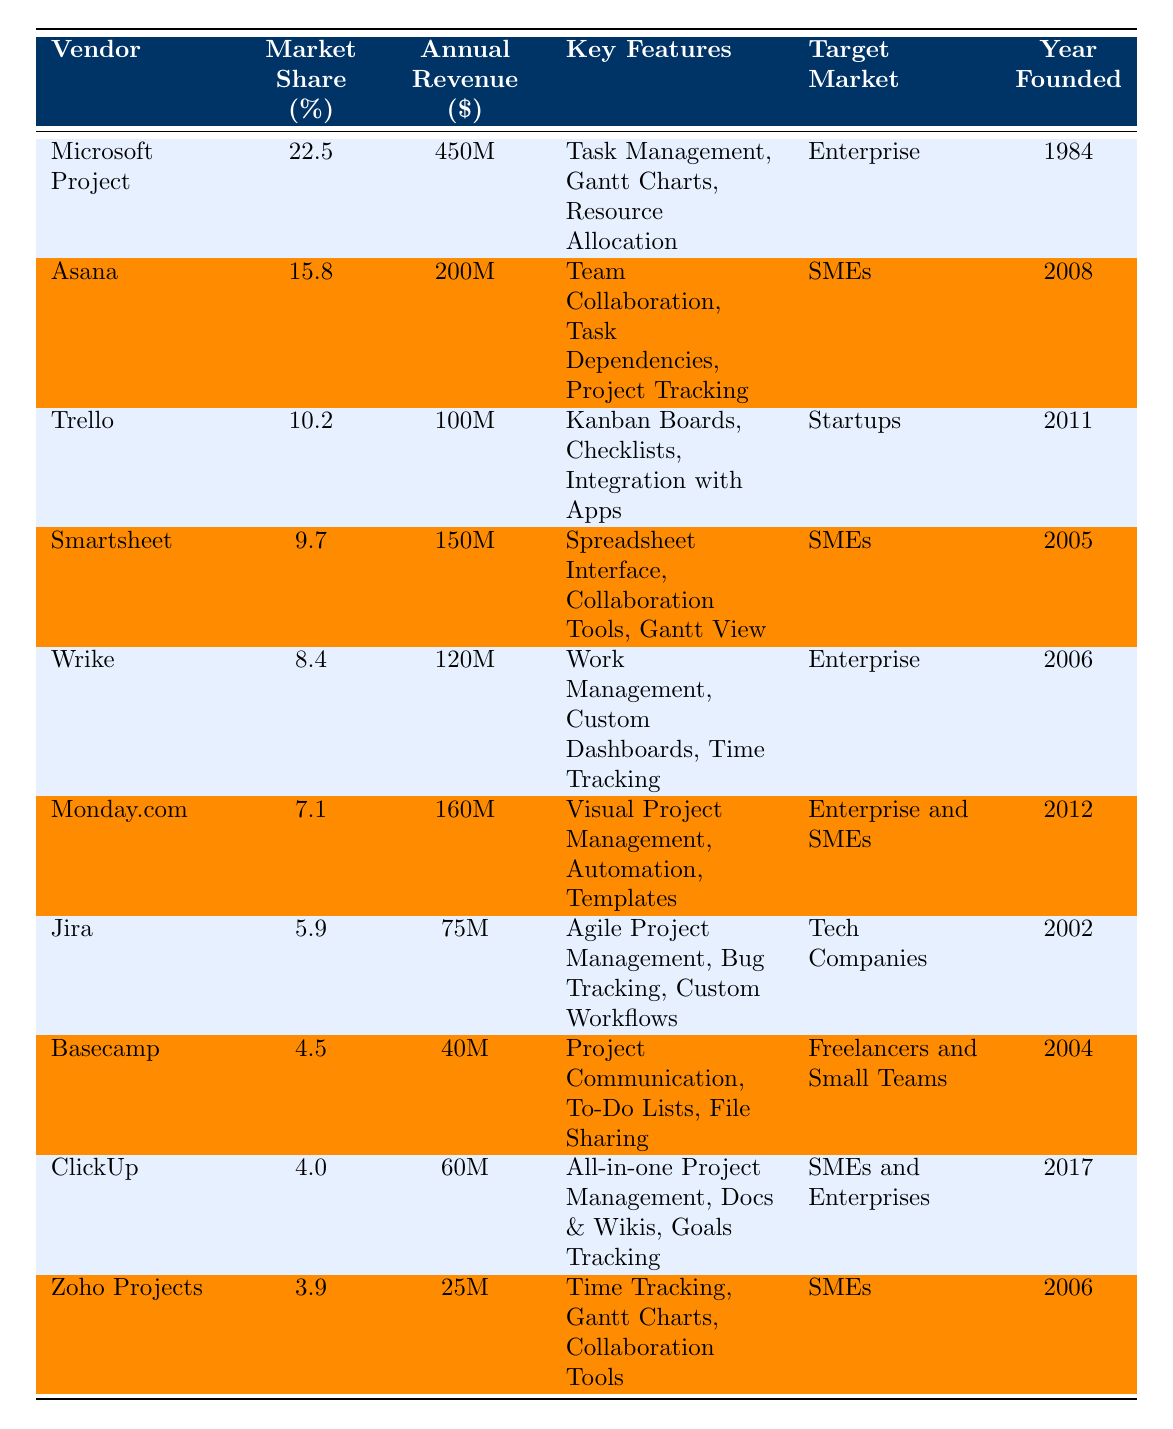What is the market share percentage of Microsoft Project? The table lists Microsoft Project with a market share percentage of 22.5%.
Answer: 22.5% Which vendor has the highest annual revenue? By examining the annual revenue column, Microsoft Project has the highest revenue of $450 million.
Answer: $450 million How many vendors target SMEs? The vendors targeting SMEs are Asana, Smartsheet, ClickUp, and Zoho Projects, totaling four vendors.
Answer: 4 What is the average market share percentage of all vendors? The total market share is 100%, and there are 10 vendors, so the average market share is 100%/10 = 10%.
Answer: 10% Which vendor was founded most recently? From the year founded column, ClickUp, founded in 2017, is the most recent.
Answer: ClickUp Is there any vendor whose annual revenue is less than $50 million? The table shows Basecamp with an annual revenue of $40 million, indicating that yes, there is a vendor below $50 million.
Answer: Yes What is the combined market share of the top three vendors? The market shares of the top three vendors are 22.5% (Microsoft Project), 15.8% (Asana), and 10.2% (Trello). Their combined market share is 22.5% + 15.8% + 10.2% = 48.5%.
Answer: 48.5% How many vendors have a market share of less than 5%? The vendors with market shares below 5% are ClickUp and Zoho Projects, totaling two vendors.
Answer: 2 What is the difference in annual revenue between Microsoft Project and Zoho Projects? Microsoft Project's revenue is $450 million and Zoho Projects is $25 million. The difference is $450 million - $25 million = $425 million.
Answer: $425 million Which vendor offers 'Gantt Charts' as a key feature and what is their market share percentage? Both Microsoft Project and Zoho Projects offer Gantt Charts. Their market shares are 22.5% and 3.9%, respectively.
Answer: Microsoft Project: 22.5%, Zoho Projects: 3.9% 